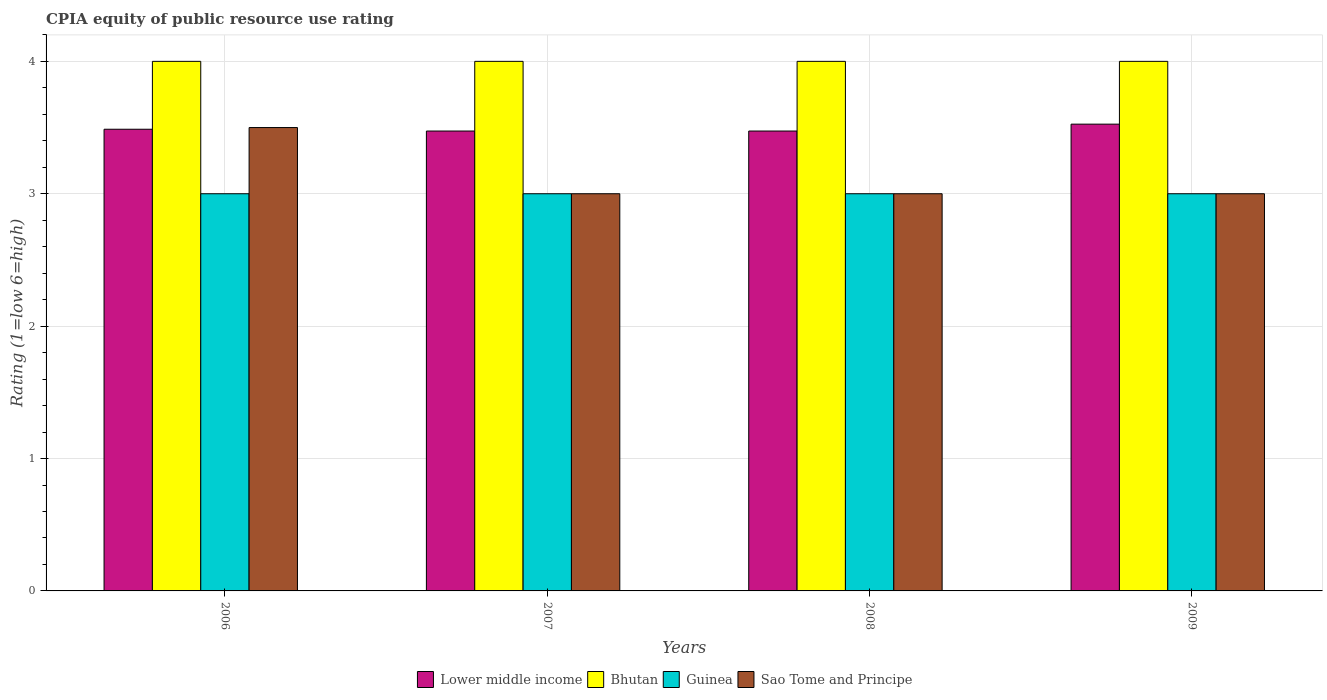How many different coloured bars are there?
Ensure brevity in your answer.  4. How many groups of bars are there?
Your response must be concise. 4. In how many cases, is the number of bars for a given year not equal to the number of legend labels?
Your answer should be compact. 0. Across all years, what is the maximum CPIA rating in Guinea?
Your response must be concise. 3. Across all years, what is the minimum CPIA rating in Guinea?
Keep it short and to the point. 3. In which year was the CPIA rating in Bhutan maximum?
Provide a short and direct response. 2006. What is the total CPIA rating in Sao Tome and Principe in the graph?
Your answer should be compact. 12.5. What is the difference between the CPIA rating in Sao Tome and Principe in 2007 and the CPIA rating in Bhutan in 2006?
Make the answer very short. -1. What is the average CPIA rating in Lower middle income per year?
Keep it short and to the point. 3.49. In the year 2009, what is the difference between the CPIA rating in Lower middle income and CPIA rating in Guinea?
Ensure brevity in your answer.  0.53. What is the ratio of the CPIA rating in Guinea in 2007 to that in 2009?
Keep it short and to the point. 1. What is the difference between the highest and the second highest CPIA rating in Bhutan?
Provide a short and direct response. 0. What is the difference between the highest and the lowest CPIA rating in Lower middle income?
Offer a terse response. 0.05. Is the sum of the CPIA rating in Lower middle income in 2007 and 2009 greater than the maximum CPIA rating in Guinea across all years?
Give a very brief answer. Yes. Is it the case that in every year, the sum of the CPIA rating in Lower middle income and CPIA rating in Bhutan is greater than the sum of CPIA rating in Guinea and CPIA rating in Sao Tome and Principe?
Your response must be concise. Yes. What does the 3rd bar from the left in 2009 represents?
Provide a short and direct response. Guinea. What does the 3rd bar from the right in 2009 represents?
Provide a succinct answer. Bhutan. Is it the case that in every year, the sum of the CPIA rating in Lower middle income and CPIA rating in Bhutan is greater than the CPIA rating in Guinea?
Your answer should be very brief. Yes. How many bars are there?
Your answer should be very brief. 16. How many years are there in the graph?
Provide a short and direct response. 4. What is the difference between two consecutive major ticks on the Y-axis?
Your answer should be compact. 1. Does the graph contain any zero values?
Offer a very short reply. No. Does the graph contain grids?
Make the answer very short. Yes. Where does the legend appear in the graph?
Your response must be concise. Bottom center. How many legend labels are there?
Your answer should be compact. 4. How are the legend labels stacked?
Offer a terse response. Horizontal. What is the title of the graph?
Your answer should be compact. CPIA equity of public resource use rating. What is the label or title of the X-axis?
Your answer should be compact. Years. What is the label or title of the Y-axis?
Provide a short and direct response. Rating (1=low 6=high). What is the Rating (1=low 6=high) in Lower middle income in 2006?
Provide a short and direct response. 3.49. What is the Rating (1=low 6=high) in Sao Tome and Principe in 2006?
Your answer should be compact. 3.5. What is the Rating (1=low 6=high) in Lower middle income in 2007?
Give a very brief answer. 3.47. What is the Rating (1=low 6=high) in Bhutan in 2007?
Your answer should be compact. 4. What is the Rating (1=low 6=high) of Lower middle income in 2008?
Provide a succinct answer. 3.47. What is the Rating (1=low 6=high) of Bhutan in 2008?
Offer a terse response. 4. What is the Rating (1=low 6=high) in Guinea in 2008?
Your response must be concise. 3. What is the Rating (1=low 6=high) in Lower middle income in 2009?
Provide a succinct answer. 3.53. What is the Rating (1=low 6=high) in Guinea in 2009?
Keep it short and to the point. 3. What is the Rating (1=low 6=high) of Sao Tome and Principe in 2009?
Provide a succinct answer. 3. Across all years, what is the maximum Rating (1=low 6=high) in Lower middle income?
Provide a succinct answer. 3.53. Across all years, what is the maximum Rating (1=low 6=high) of Bhutan?
Offer a terse response. 4. Across all years, what is the maximum Rating (1=low 6=high) of Sao Tome and Principe?
Keep it short and to the point. 3.5. Across all years, what is the minimum Rating (1=low 6=high) of Lower middle income?
Offer a very short reply. 3.47. What is the total Rating (1=low 6=high) of Lower middle income in the graph?
Keep it short and to the point. 13.96. What is the total Rating (1=low 6=high) in Bhutan in the graph?
Your response must be concise. 16. What is the total Rating (1=low 6=high) of Guinea in the graph?
Keep it short and to the point. 12. What is the total Rating (1=low 6=high) of Sao Tome and Principe in the graph?
Make the answer very short. 12.5. What is the difference between the Rating (1=low 6=high) of Lower middle income in 2006 and that in 2007?
Provide a short and direct response. 0.01. What is the difference between the Rating (1=low 6=high) of Guinea in 2006 and that in 2007?
Offer a terse response. 0. What is the difference between the Rating (1=low 6=high) in Lower middle income in 2006 and that in 2008?
Make the answer very short. 0.01. What is the difference between the Rating (1=low 6=high) in Bhutan in 2006 and that in 2008?
Keep it short and to the point. 0. What is the difference between the Rating (1=low 6=high) in Sao Tome and Principe in 2006 and that in 2008?
Offer a very short reply. 0.5. What is the difference between the Rating (1=low 6=high) in Lower middle income in 2006 and that in 2009?
Your response must be concise. -0.04. What is the difference between the Rating (1=low 6=high) of Guinea in 2006 and that in 2009?
Offer a very short reply. 0. What is the difference between the Rating (1=low 6=high) in Lower middle income in 2007 and that in 2008?
Your response must be concise. 0. What is the difference between the Rating (1=low 6=high) of Bhutan in 2007 and that in 2008?
Offer a terse response. 0. What is the difference between the Rating (1=low 6=high) in Sao Tome and Principe in 2007 and that in 2008?
Keep it short and to the point. 0. What is the difference between the Rating (1=low 6=high) in Lower middle income in 2007 and that in 2009?
Provide a succinct answer. -0.05. What is the difference between the Rating (1=low 6=high) of Guinea in 2007 and that in 2009?
Your answer should be very brief. 0. What is the difference between the Rating (1=low 6=high) of Sao Tome and Principe in 2007 and that in 2009?
Provide a succinct answer. 0. What is the difference between the Rating (1=low 6=high) of Lower middle income in 2008 and that in 2009?
Ensure brevity in your answer.  -0.05. What is the difference between the Rating (1=low 6=high) in Guinea in 2008 and that in 2009?
Provide a short and direct response. 0. What is the difference between the Rating (1=low 6=high) in Lower middle income in 2006 and the Rating (1=low 6=high) in Bhutan in 2007?
Your answer should be compact. -0.51. What is the difference between the Rating (1=low 6=high) in Lower middle income in 2006 and the Rating (1=low 6=high) in Guinea in 2007?
Offer a very short reply. 0.49. What is the difference between the Rating (1=low 6=high) in Lower middle income in 2006 and the Rating (1=low 6=high) in Sao Tome and Principe in 2007?
Provide a succinct answer. 0.49. What is the difference between the Rating (1=low 6=high) of Bhutan in 2006 and the Rating (1=low 6=high) of Guinea in 2007?
Provide a short and direct response. 1. What is the difference between the Rating (1=low 6=high) in Guinea in 2006 and the Rating (1=low 6=high) in Sao Tome and Principe in 2007?
Make the answer very short. 0. What is the difference between the Rating (1=low 6=high) in Lower middle income in 2006 and the Rating (1=low 6=high) in Bhutan in 2008?
Keep it short and to the point. -0.51. What is the difference between the Rating (1=low 6=high) in Lower middle income in 2006 and the Rating (1=low 6=high) in Guinea in 2008?
Your response must be concise. 0.49. What is the difference between the Rating (1=low 6=high) in Lower middle income in 2006 and the Rating (1=low 6=high) in Sao Tome and Principe in 2008?
Ensure brevity in your answer.  0.49. What is the difference between the Rating (1=low 6=high) in Bhutan in 2006 and the Rating (1=low 6=high) in Sao Tome and Principe in 2008?
Keep it short and to the point. 1. What is the difference between the Rating (1=low 6=high) in Lower middle income in 2006 and the Rating (1=low 6=high) in Bhutan in 2009?
Offer a very short reply. -0.51. What is the difference between the Rating (1=low 6=high) in Lower middle income in 2006 and the Rating (1=low 6=high) in Guinea in 2009?
Your response must be concise. 0.49. What is the difference between the Rating (1=low 6=high) of Lower middle income in 2006 and the Rating (1=low 6=high) of Sao Tome and Principe in 2009?
Offer a terse response. 0.49. What is the difference between the Rating (1=low 6=high) of Bhutan in 2006 and the Rating (1=low 6=high) of Guinea in 2009?
Offer a terse response. 1. What is the difference between the Rating (1=low 6=high) in Guinea in 2006 and the Rating (1=low 6=high) in Sao Tome and Principe in 2009?
Offer a terse response. 0. What is the difference between the Rating (1=low 6=high) of Lower middle income in 2007 and the Rating (1=low 6=high) of Bhutan in 2008?
Make the answer very short. -0.53. What is the difference between the Rating (1=low 6=high) of Lower middle income in 2007 and the Rating (1=low 6=high) of Guinea in 2008?
Your answer should be very brief. 0.47. What is the difference between the Rating (1=low 6=high) of Lower middle income in 2007 and the Rating (1=low 6=high) of Sao Tome and Principe in 2008?
Offer a terse response. 0.47. What is the difference between the Rating (1=low 6=high) in Bhutan in 2007 and the Rating (1=low 6=high) in Guinea in 2008?
Offer a terse response. 1. What is the difference between the Rating (1=low 6=high) of Bhutan in 2007 and the Rating (1=low 6=high) of Sao Tome and Principe in 2008?
Give a very brief answer. 1. What is the difference between the Rating (1=low 6=high) in Lower middle income in 2007 and the Rating (1=low 6=high) in Bhutan in 2009?
Offer a very short reply. -0.53. What is the difference between the Rating (1=low 6=high) in Lower middle income in 2007 and the Rating (1=low 6=high) in Guinea in 2009?
Your response must be concise. 0.47. What is the difference between the Rating (1=low 6=high) in Lower middle income in 2007 and the Rating (1=low 6=high) in Sao Tome and Principe in 2009?
Make the answer very short. 0.47. What is the difference between the Rating (1=low 6=high) in Bhutan in 2007 and the Rating (1=low 6=high) in Sao Tome and Principe in 2009?
Your answer should be very brief. 1. What is the difference between the Rating (1=low 6=high) of Guinea in 2007 and the Rating (1=low 6=high) of Sao Tome and Principe in 2009?
Your answer should be very brief. 0. What is the difference between the Rating (1=low 6=high) of Lower middle income in 2008 and the Rating (1=low 6=high) of Bhutan in 2009?
Give a very brief answer. -0.53. What is the difference between the Rating (1=low 6=high) of Lower middle income in 2008 and the Rating (1=low 6=high) of Guinea in 2009?
Keep it short and to the point. 0.47. What is the difference between the Rating (1=low 6=high) in Lower middle income in 2008 and the Rating (1=low 6=high) in Sao Tome and Principe in 2009?
Offer a very short reply. 0.47. What is the difference between the Rating (1=low 6=high) in Bhutan in 2008 and the Rating (1=low 6=high) in Sao Tome and Principe in 2009?
Your response must be concise. 1. What is the average Rating (1=low 6=high) of Lower middle income per year?
Provide a succinct answer. 3.49. What is the average Rating (1=low 6=high) of Guinea per year?
Ensure brevity in your answer.  3. What is the average Rating (1=low 6=high) of Sao Tome and Principe per year?
Keep it short and to the point. 3.12. In the year 2006, what is the difference between the Rating (1=low 6=high) in Lower middle income and Rating (1=low 6=high) in Bhutan?
Offer a very short reply. -0.51. In the year 2006, what is the difference between the Rating (1=low 6=high) of Lower middle income and Rating (1=low 6=high) of Guinea?
Keep it short and to the point. 0.49. In the year 2006, what is the difference between the Rating (1=low 6=high) in Lower middle income and Rating (1=low 6=high) in Sao Tome and Principe?
Provide a short and direct response. -0.01. In the year 2007, what is the difference between the Rating (1=low 6=high) in Lower middle income and Rating (1=low 6=high) in Bhutan?
Offer a very short reply. -0.53. In the year 2007, what is the difference between the Rating (1=low 6=high) of Lower middle income and Rating (1=low 6=high) of Guinea?
Give a very brief answer. 0.47. In the year 2007, what is the difference between the Rating (1=low 6=high) in Lower middle income and Rating (1=low 6=high) in Sao Tome and Principe?
Keep it short and to the point. 0.47. In the year 2007, what is the difference between the Rating (1=low 6=high) in Bhutan and Rating (1=low 6=high) in Sao Tome and Principe?
Keep it short and to the point. 1. In the year 2007, what is the difference between the Rating (1=low 6=high) in Guinea and Rating (1=low 6=high) in Sao Tome and Principe?
Your response must be concise. 0. In the year 2008, what is the difference between the Rating (1=low 6=high) in Lower middle income and Rating (1=low 6=high) in Bhutan?
Offer a terse response. -0.53. In the year 2008, what is the difference between the Rating (1=low 6=high) of Lower middle income and Rating (1=low 6=high) of Guinea?
Give a very brief answer. 0.47. In the year 2008, what is the difference between the Rating (1=low 6=high) of Lower middle income and Rating (1=low 6=high) of Sao Tome and Principe?
Give a very brief answer. 0.47. In the year 2008, what is the difference between the Rating (1=low 6=high) in Bhutan and Rating (1=low 6=high) in Guinea?
Your answer should be very brief. 1. In the year 2008, what is the difference between the Rating (1=low 6=high) in Bhutan and Rating (1=low 6=high) in Sao Tome and Principe?
Keep it short and to the point. 1. In the year 2009, what is the difference between the Rating (1=low 6=high) of Lower middle income and Rating (1=low 6=high) of Bhutan?
Provide a succinct answer. -0.47. In the year 2009, what is the difference between the Rating (1=low 6=high) in Lower middle income and Rating (1=low 6=high) in Guinea?
Ensure brevity in your answer.  0.53. In the year 2009, what is the difference between the Rating (1=low 6=high) of Lower middle income and Rating (1=low 6=high) of Sao Tome and Principe?
Your answer should be very brief. 0.53. In the year 2009, what is the difference between the Rating (1=low 6=high) in Bhutan and Rating (1=low 6=high) in Sao Tome and Principe?
Offer a very short reply. 1. What is the ratio of the Rating (1=low 6=high) of Bhutan in 2006 to that in 2007?
Give a very brief answer. 1. What is the ratio of the Rating (1=low 6=high) of Guinea in 2006 to that in 2007?
Your answer should be very brief. 1. What is the ratio of the Rating (1=low 6=high) in Sao Tome and Principe in 2006 to that in 2007?
Provide a succinct answer. 1.17. What is the ratio of the Rating (1=low 6=high) in Bhutan in 2006 to that in 2008?
Make the answer very short. 1. What is the ratio of the Rating (1=low 6=high) of Sao Tome and Principe in 2006 to that in 2008?
Your response must be concise. 1.17. What is the ratio of the Rating (1=low 6=high) of Lower middle income in 2006 to that in 2009?
Make the answer very short. 0.99. What is the ratio of the Rating (1=low 6=high) in Bhutan in 2006 to that in 2009?
Give a very brief answer. 1. What is the ratio of the Rating (1=low 6=high) in Bhutan in 2007 to that in 2008?
Provide a succinct answer. 1. What is the ratio of the Rating (1=low 6=high) of Sao Tome and Principe in 2007 to that in 2008?
Offer a very short reply. 1. What is the ratio of the Rating (1=low 6=high) in Lower middle income in 2007 to that in 2009?
Your answer should be very brief. 0.99. What is the ratio of the Rating (1=low 6=high) of Sao Tome and Principe in 2007 to that in 2009?
Your answer should be very brief. 1. What is the ratio of the Rating (1=low 6=high) of Bhutan in 2008 to that in 2009?
Your response must be concise. 1. What is the ratio of the Rating (1=low 6=high) of Sao Tome and Principe in 2008 to that in 2009?
Offer a very short reply. 1. What is the difference between the highest and the second highest Rating (1=low 6=high) of Lower middle income?
Give a very brief answer. 0.04. What is the difference between the highest and the second highest Rating (1=low 6=high) of Bhutan?
Your answer should be compact. 0. What is the difference between the highest and the lowest Rating (1=low 6=high) of Lower middle income?
Offer a very short reply. 0.05. What is the difference between the highest and the lowest Rating (1=low 6=high) of Bhutan?
Ensure brevity in your answer.  0. What is the difference between the highest and the lowest Rating (1=low 6=high) of Guinea?
Keep it short and to the point. 0. What is the difference between the highest and the lowest Rating (1=low 6=high) of Sao Tome and Principe?
Make the answer very short. 0.5. 